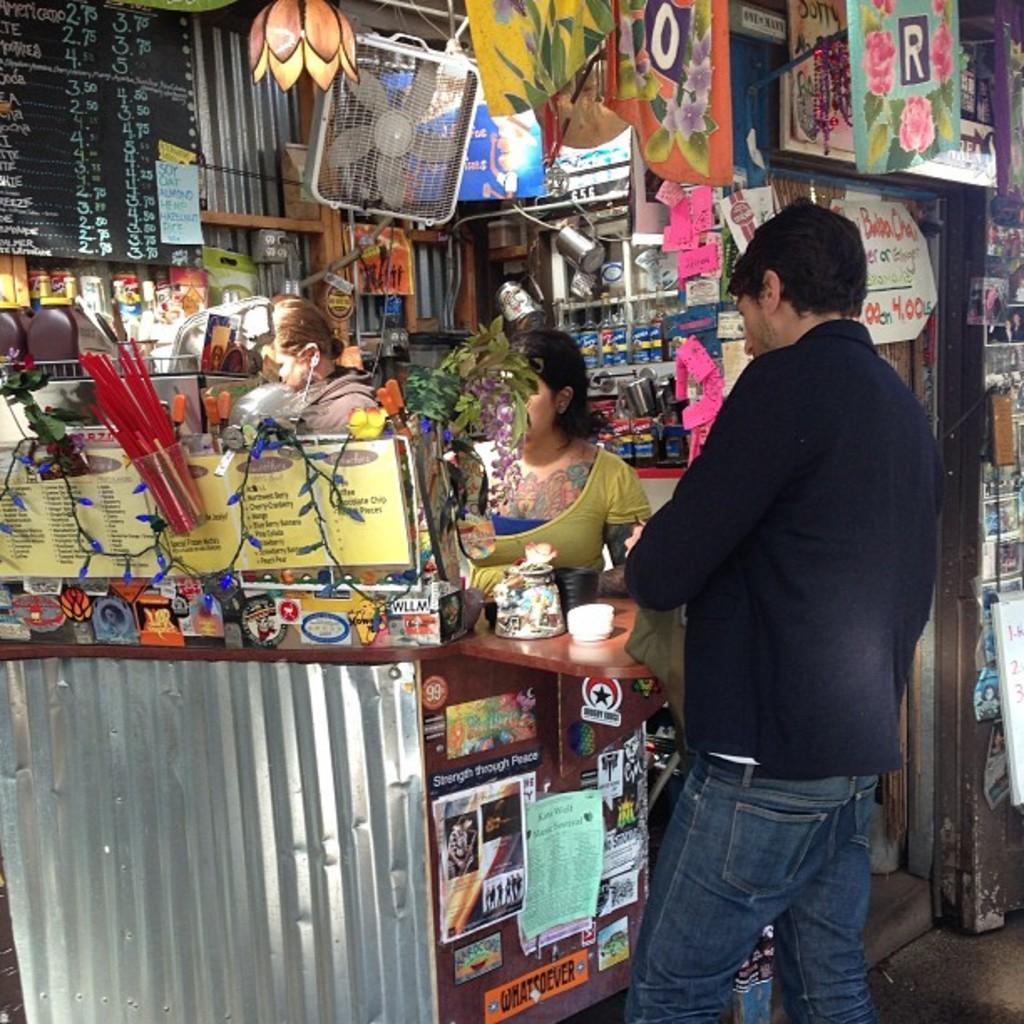What letter is written on the orange banner on the top?
Make the answer very short. O. Which letter is written on the turquoise banner?
Give a very brief answer. R. 